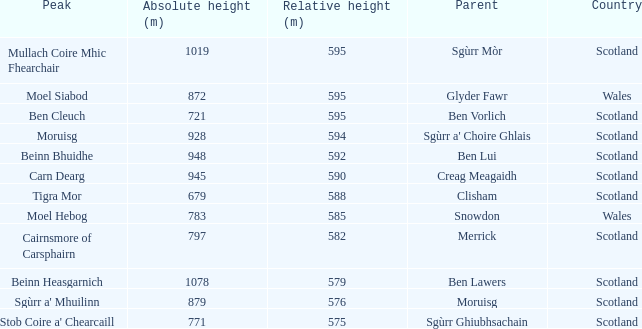What is the comparative elevation of scotland with ben vorlich as the origin? 1.0. 